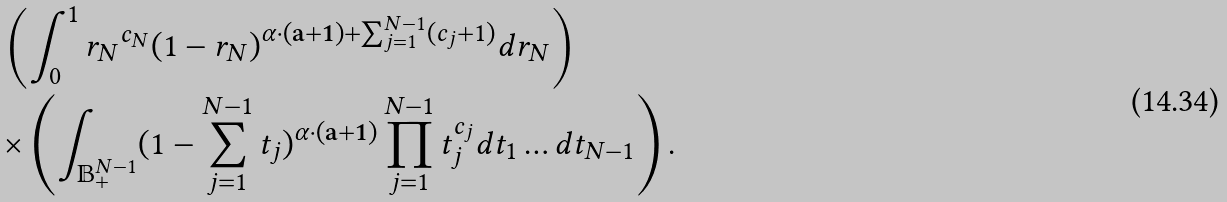Convert formula to latex. <formula><loc_0><loc_0><loc_500><loc_500>& \left ( \int _ { 0 } ^ { 1 } { r _ { N } } ^ { c _ { N } } ( 1 - r _ { N } ) ^ { \alpha \cdot ( \mathbf a + \mathbf 1 ) + \sum _ { j = 1 } ^ { N - 1 } ( c _ { j } + 1 ) } d r _ { N } \right ) \\ & \times \left ( \int _ { \mathbb { B } ^ { N - 1 } _ { + } } ( 1 - \sum _ { j = 1 } ^ { N - 1 } t _ { j } ) ^ { \alpha \cdot ( \mathbf a + \mathbf 1 ) } \prod _ { j = 1 } ^ { N - 1 } t _ { j } ^ { c _ { j } } d t _ { 1 } \dots d t _ { N - 1 } \right ) .</formula> 